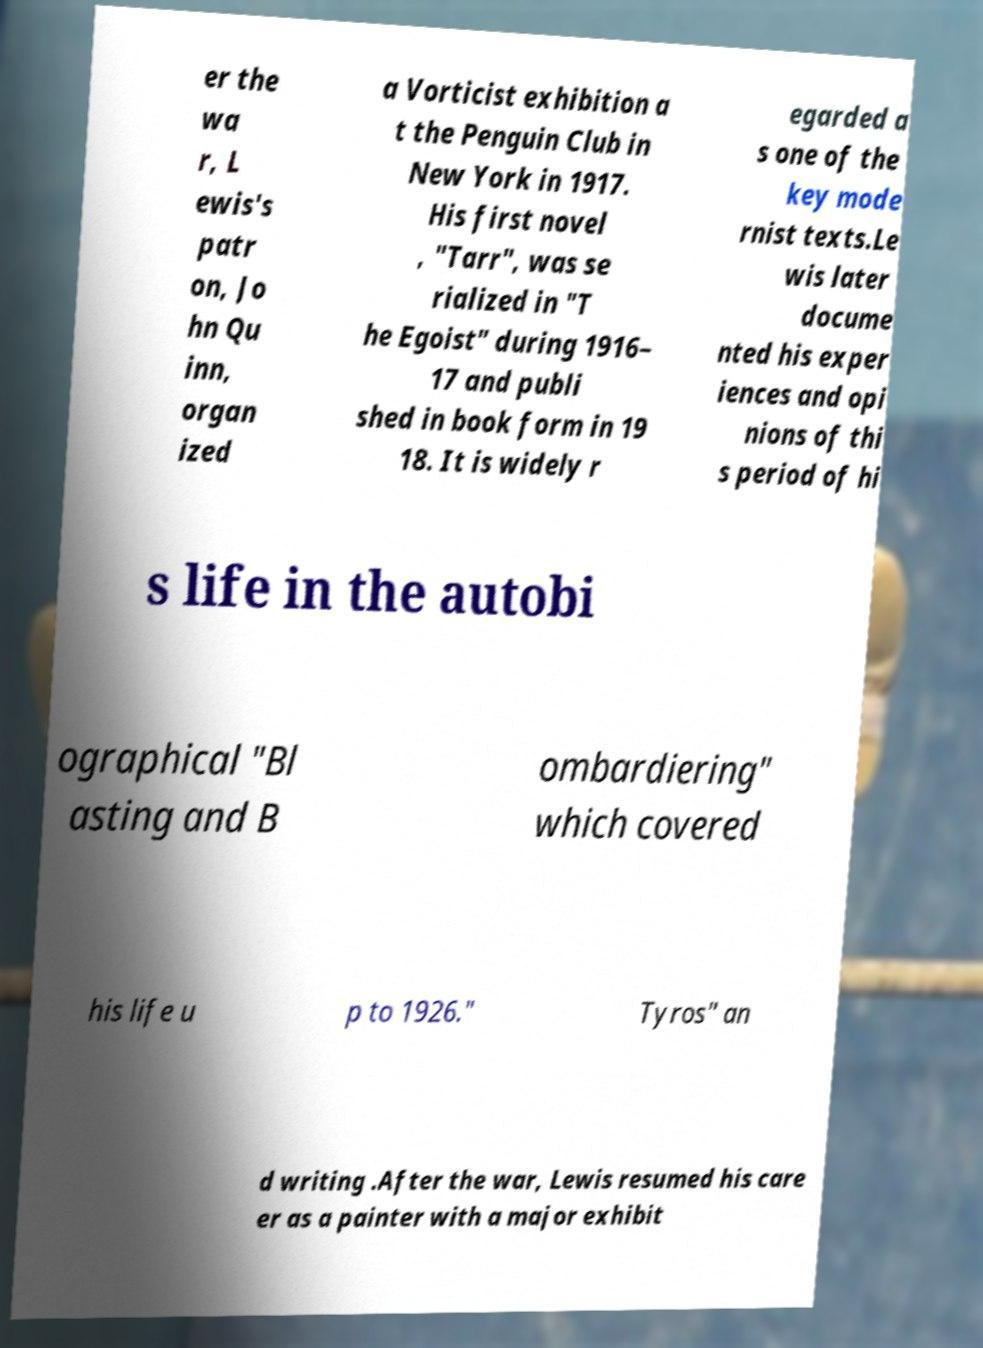Could you assist in decoding the text presented in this image and type it out clearly? er the wa r, L ewis's patr on, Jo hn Qu inn, organ ized a Vorticist exhibition a t the Penguin Club in New York in 1917. His first novel , "Tarr", was se rialized in "T he Egoist" during 1916– 17 and publi shed in book form in 19 18. It is widely r egarded a s one of the key mode rnist texts.Le wis later docume nted his exper iences and opi nions of thi s period of hi s life in the autobi ographical "Bl asting and B ombardiering" which covered his life u p to 1926." Tyros" an d writing .After the war, Lewis resumed his care er as a painter with a major exhibit 